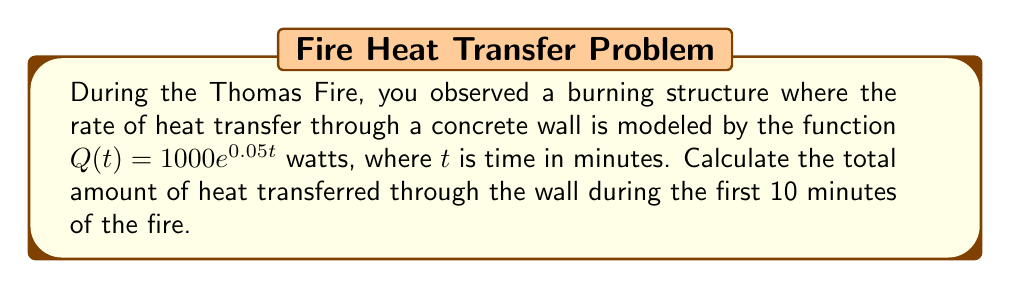Can you answer this question? To solve this problem, we need to integrate the heat transfer rate function over the given time interval. Here's how we approach it:

1) The heat transfer rate is given by $Q(t) = 1000e^{0.05t}$ watts.

2) To find the total heat transferred, we need to integrate this function from $t=0$ to $t=10$:

   $$\text{Total Heat} = \int_0^{10} Q(t) dt = \int_0^{10} 1000e^{0.05t} dt$$

3) Let's solve this integral:
   
   $$\int_0^{10} 1000e^{0.05t} dt = 1000 \int_0^{10} e^{0.05t} dt$$

4) We can solve this using the substitution method or by recalling that the integral of $e^{ax}$ is $\frac{1}{a}e^{ax} + C$:

   $$1000 \int_0^{10} e^{0.05t} dt = 1000 \cdot \frac{1}{0.05} e^{0.05t} \bigg|_0^{10}$$

5) Now, let's evaluate this:

   $$= 20000 \cdot (e^{0.5} - e^0)$$
   $$= 20000 \cdot (1.6487 - 1)$$
   $$= 20000 \cdot 0.6487$$
   $$= 12974 \text{ watt-minutes}$$

6) Convert watt-minutes to joules:
   1 watt-minute = 60 joules
   
   $12974 \text{ watt-minutes} \cdot 60 \text{ joules/watt-minute} = 778440 \text{ joules}$
Answer: The total amount of heat transferred through the wall during the first 10 minutes of the fire is approximately 778,440 joules. 